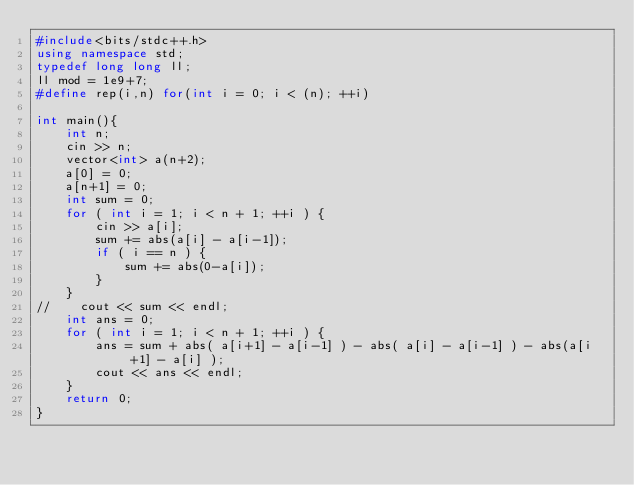Convert code to text. <code><loc_0><loc_0><loc_500><loc_500><_C++_>#include<bits/stdc++.h>
using namespace std;
typedef long long ll;
ll mod = 1e9+7;
#define rep(i,n) for(int i = 0; i < (n); ++i)

int main(){
    int n;
    cin >> n;
    vector<int> a(n+2);
    a[0] = 0;
    a[n+1] = 0;
    int sum = 0;
    for ( int i = 1; i < n + 1; ++i ) {
        cin >> a[i];
        sum += abs(a[i] - a[i-1]);
        if ( i == n ) {
            sum += abs(0-a[i]);
        }
    }
//    cout << sum << endl;
    int ans = 0;
    for ( int i = 1; i < n + 1; ++i ) {
        ans = sum + abs( a[i+1] - a[i-1] ) - abs( a[i] - a[i-1] ) - abs(a[i+1] - a[i] );
        cout << ans << endl;
    }
    return 0;
}
</code> 